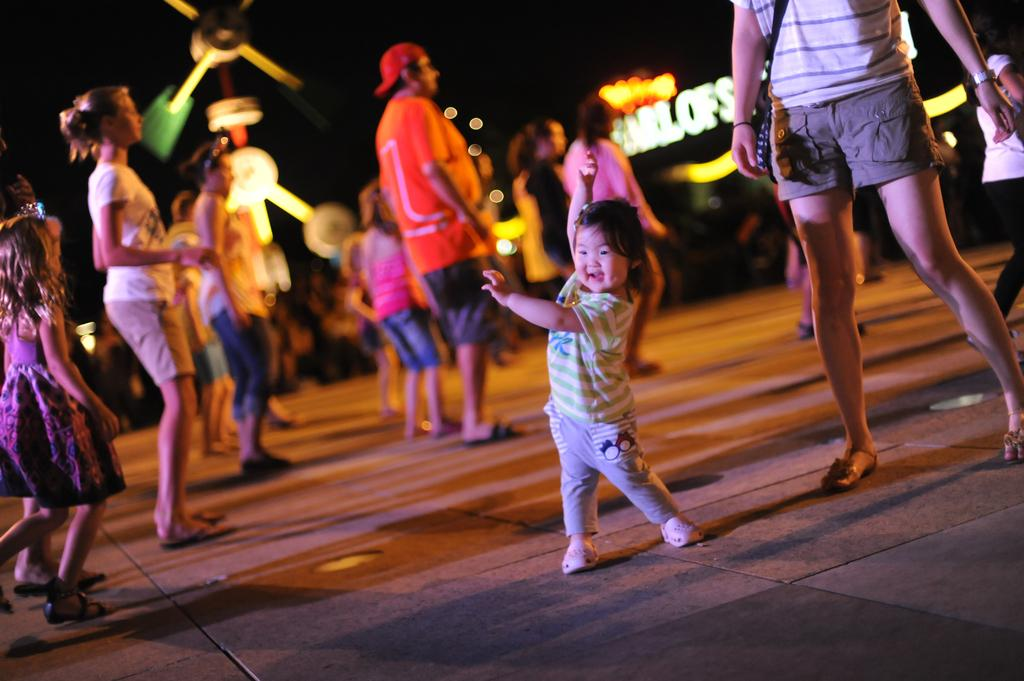What is the main subject of the image? The main subject of the image is a kid. What is the kid doing in the image? The kid is dancing on the floor. Can you describe the background of the image? The background is blurred, and there are people dancing in it. What type of notebook is the kid using to write down their dance steps in the image? There is no notebook present in the image, and the kid is not writing down any dance steps. 